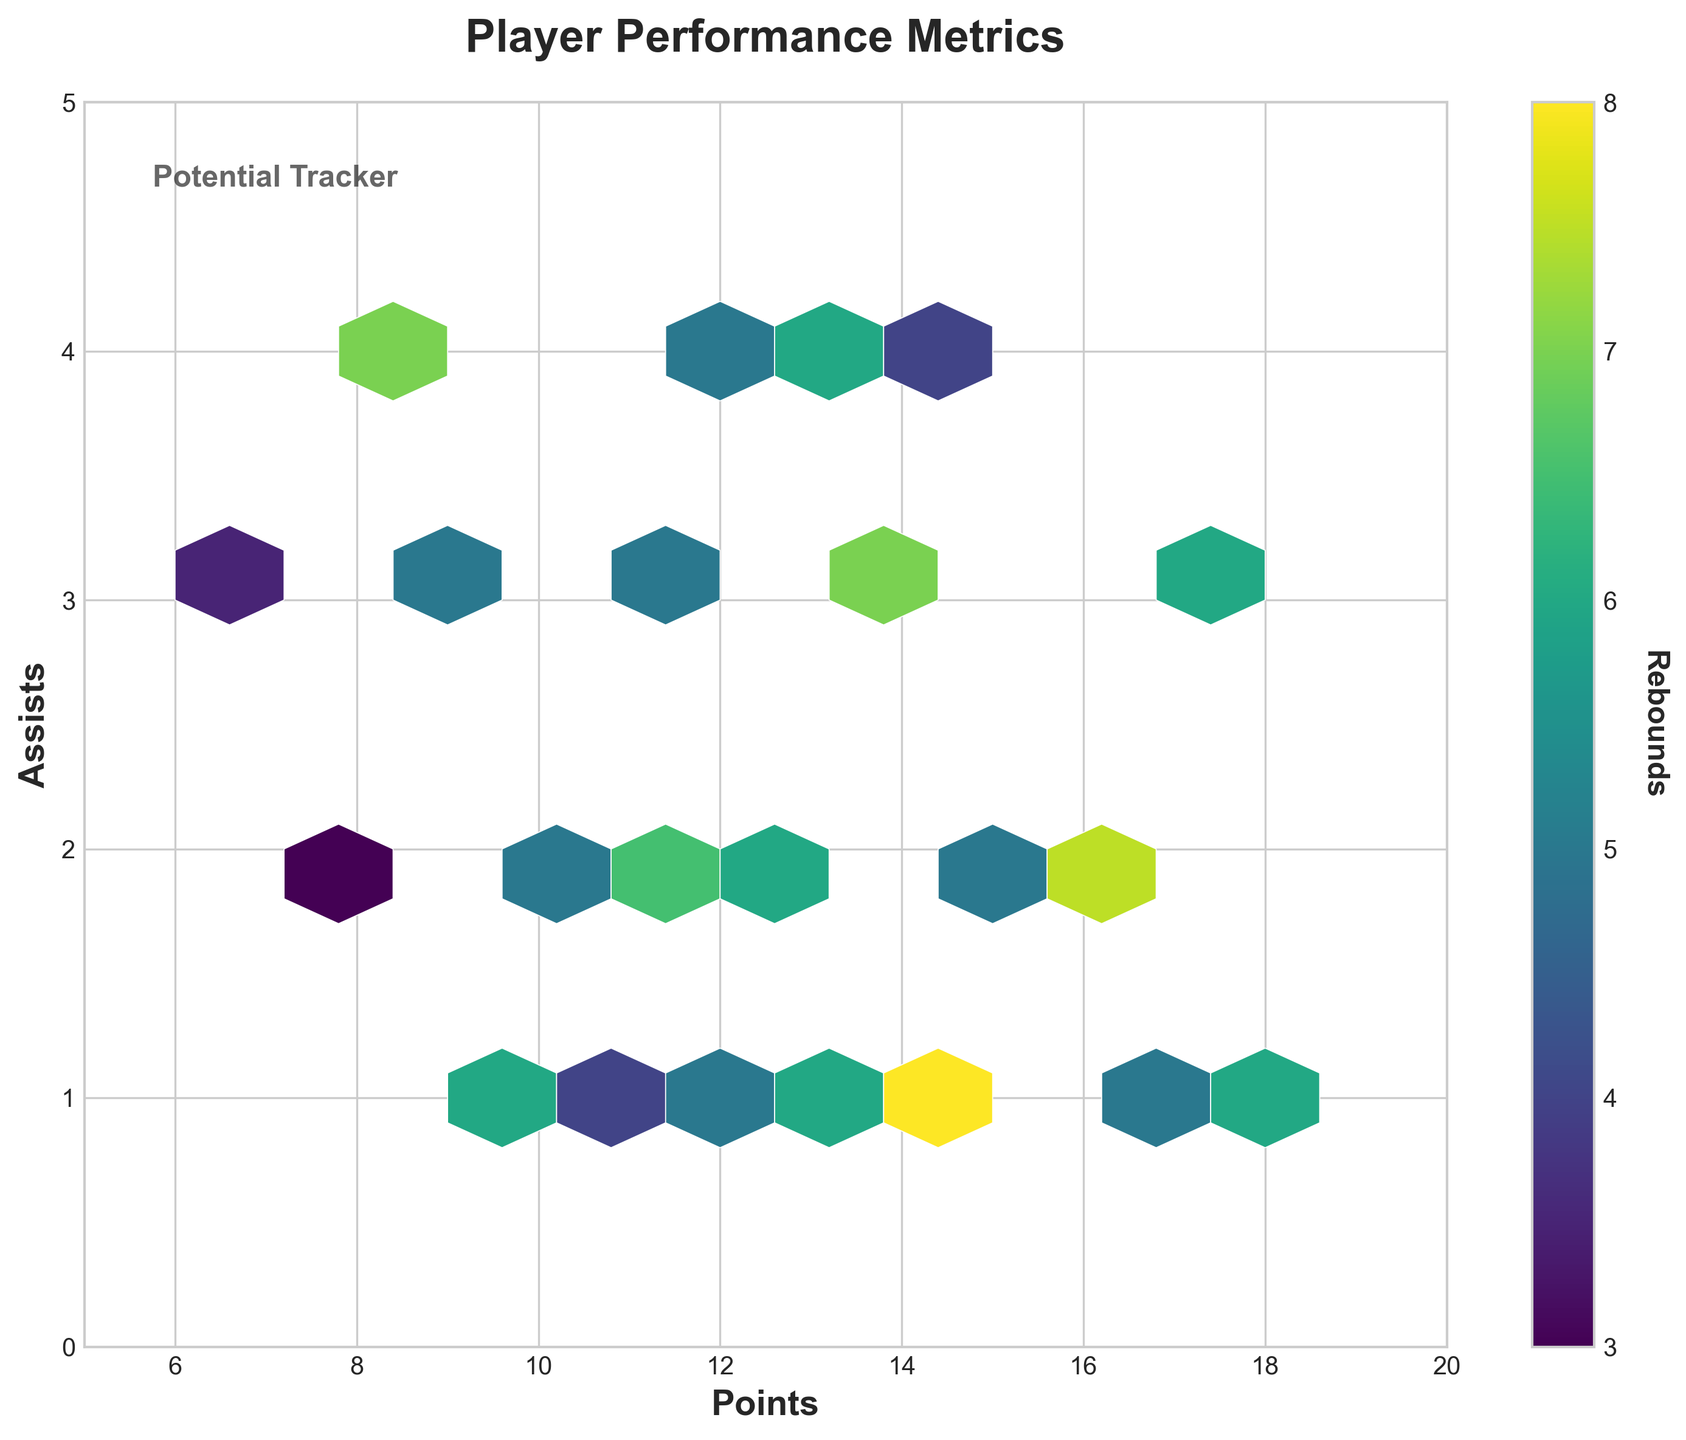How many points does the highest hexagon in the plot have? To determine this, observe the x-axis (Points) and locate the position of the highest concentration hexagon within the range. The highest hexagons for Points appear at around the range of 10-15 points.
Answer: 10-15 What is the title of the plot? The plot has a clear title at the top of the figure.
Answer: Player Performance Metrics What are the ranges for the x-axis and y-axis in the plot? The x-axis (Points) ranges from 5 to 20, and the y-axis (Assists) ranges from 0 to 5. This information can be found by looking at the labels and ticks on the axes.
Answer: Points: 5-20, Assists: 0-5 What does the color in the hexagons represent? The color in the hexagons represents the number of Rebounds. This information is shown in the color bar to the right of the plot, which is labeled accordingly.
Answer: Rebounds Which bin has the highest average assists? To find the hexagon with the highest average assists, locate the bin along the y-axis range (0-5) with the highest concentration or darkest color.
Answer: Bin around 2 assists Which bin has the highest number of points and is the darkest on the plot? Find the darkest hexagon in the plot, which shows the highest value for rebounds. Cross-reference its location with the x-axis to see the number of points. The darkest hexagon is around 12-15 points.
Answer: 12-15 points Do more points generally correlate with more assists based on this plot? To determine the correlation, observe the overall spread of hexagons. If they trend upward/rightward, there’s a positive correlation. The points and assists seem to spread without a clear upward or downward trend, indicating no strong correlation.
Answer: No strong correlation What visual element indicates the range of rebound values in this plot? The color bar on the right side of the plot indicates the range of values for rebounds, explaining different shades in the hexagon bins.
Answer: Color bar Which range of Rebounds appears most frequently in the plot? Observe the color of the hexagons and refer to the color bar. The most frequent (densely colored) range appears between 5 and 7 rebounds.
Answer: 5-7 rebounds Are there more players with high points or high assists? Based on the density of hexagons along the x and y axes, there are more hexagons (density) towards higher points (right side) than higher assists (top side).
Answer: High points 